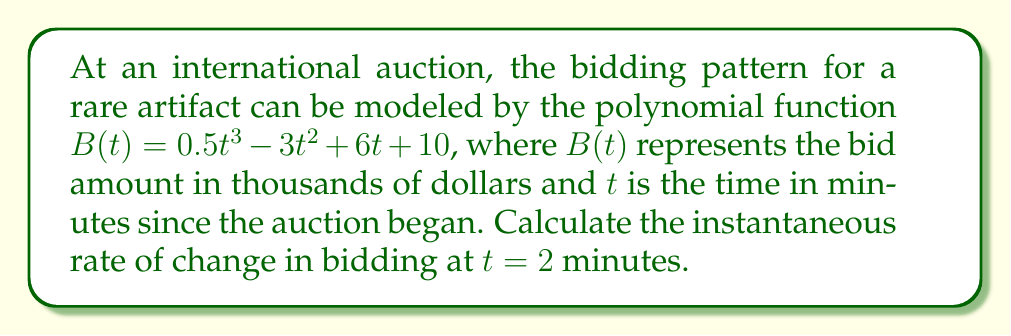Can you answer this question? To find the instantaneous rate of change at a specific point, we need to calculate the derivative of the function and evaluate it at the given point. Here's how we do it:

1) The given function is $B(t) = 0.5t^3 - 3t^2 + 6t + 10$

2) To find the derivative, we apply the power rule and constant rule:
   $$B'(t) = 1.5t^2 - 6t + 6$$

3) Now, we need to evaluate $B'(t)$ at $t = 2$:
   $$B'(2) = 1.5(2)^2 - 6(2) + 6$$
   $$= 1.5(4) - 12 + 6$$
   $$= 6 - 12 + 6$$
   $$= 0$$

4) The units of the rate of change will be thousands of dollars per minute.

Therefore, the instantaneous rate of change in bidding at $t = 2$ minutes is 0 thousand dollars per minute.
Answer: 0 thousand dollars per minute 